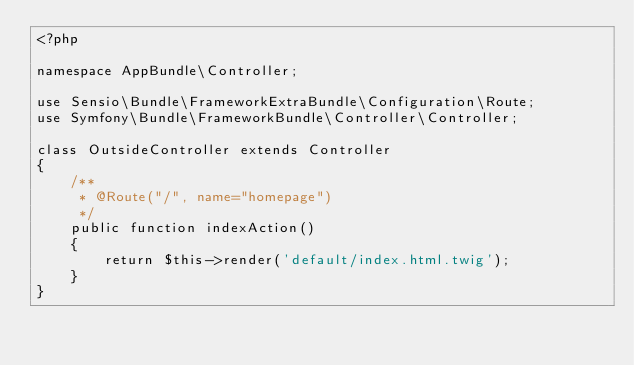Convert code to text. <code><loc_0><loc_0><loc_500><loc_500><_PHP_><?php

namespace AppBundle\Controller;

use Sensio\Bundle\FrameworkExtraBundle\Configuration\Route;
use Symfony\Bundle\FrameworkBundle\Controller\Controller;

class OutsideController extends Controller
{
    /**
     * @Route("/", name="homepage")
     */
    public function indexAction()
    {
        return $this->render('default/index.html.twig');
    }
}
</code> 